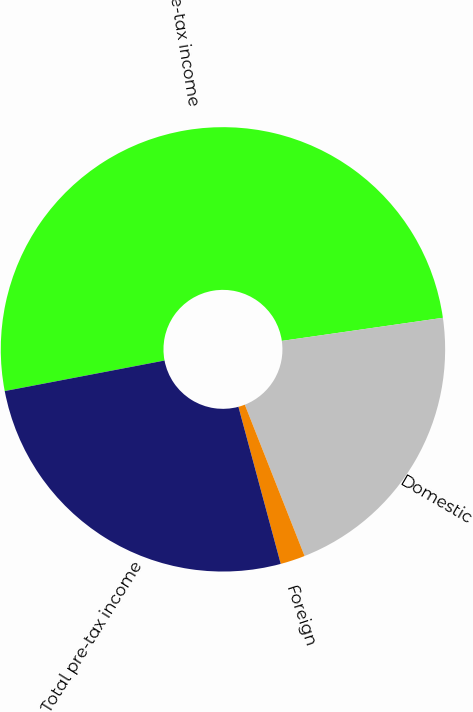Convert chart. <chart><loc_0><loc_0><loc_500><loc_500><pie_chart><fcel>Pre-tax income<fcel>Domestic<fcel>Foreign<fcel>Total pre-tax income<nl><fcel>50.74%<fcel>21.28%<fcel>1.8%<fcel>26.18%<nl></chart> 